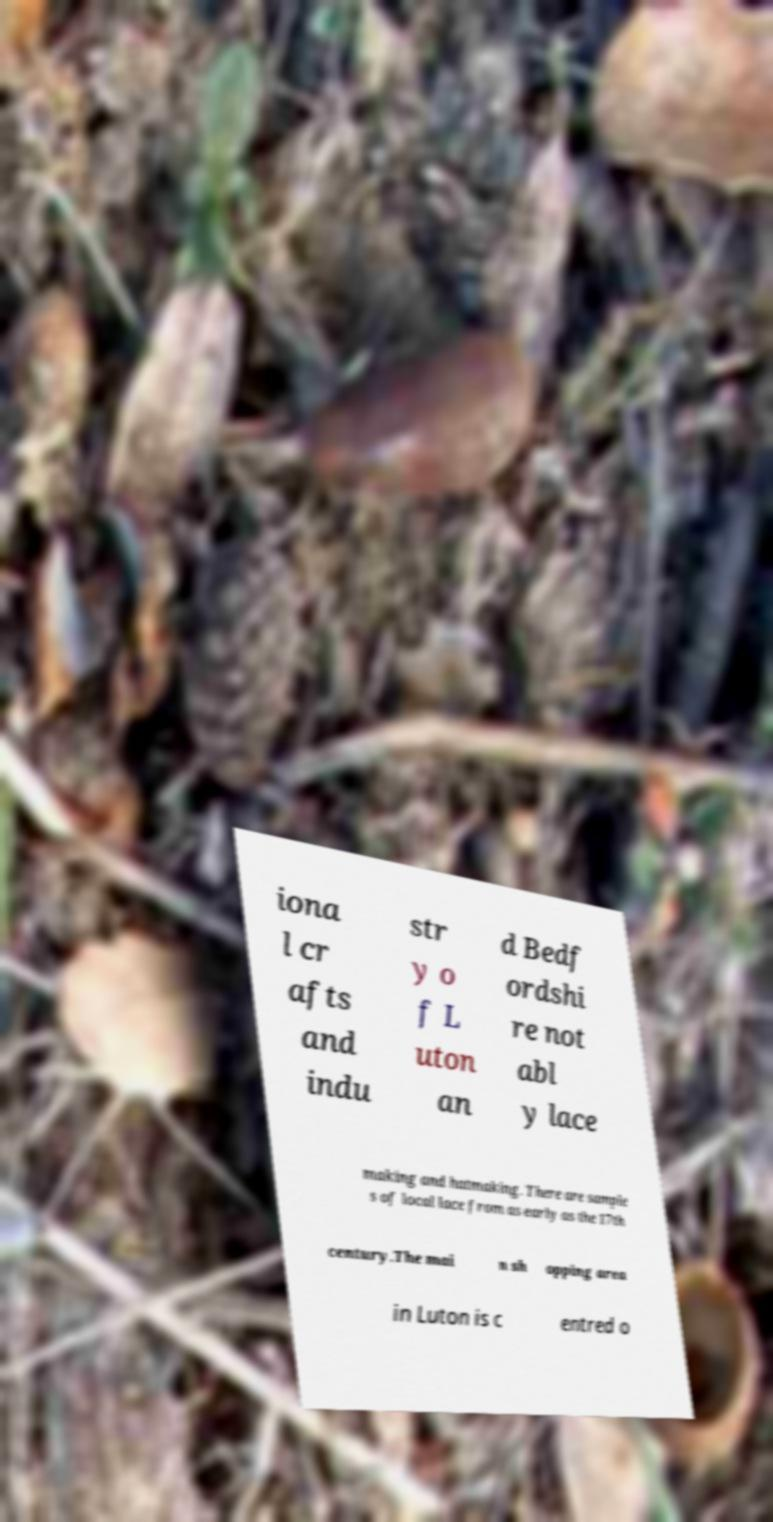Can you read and provide the text displayed in the image?This photo seems to have some interesting text. Can you extract and type it out for me? iona l cr afts and indu str y o f L uton an d Bedf ordshi re not abl y lace making and hatmaking. There are sample s of local lace from as early as the 17th century.The mai n sh opping area in Luton is c entred o 